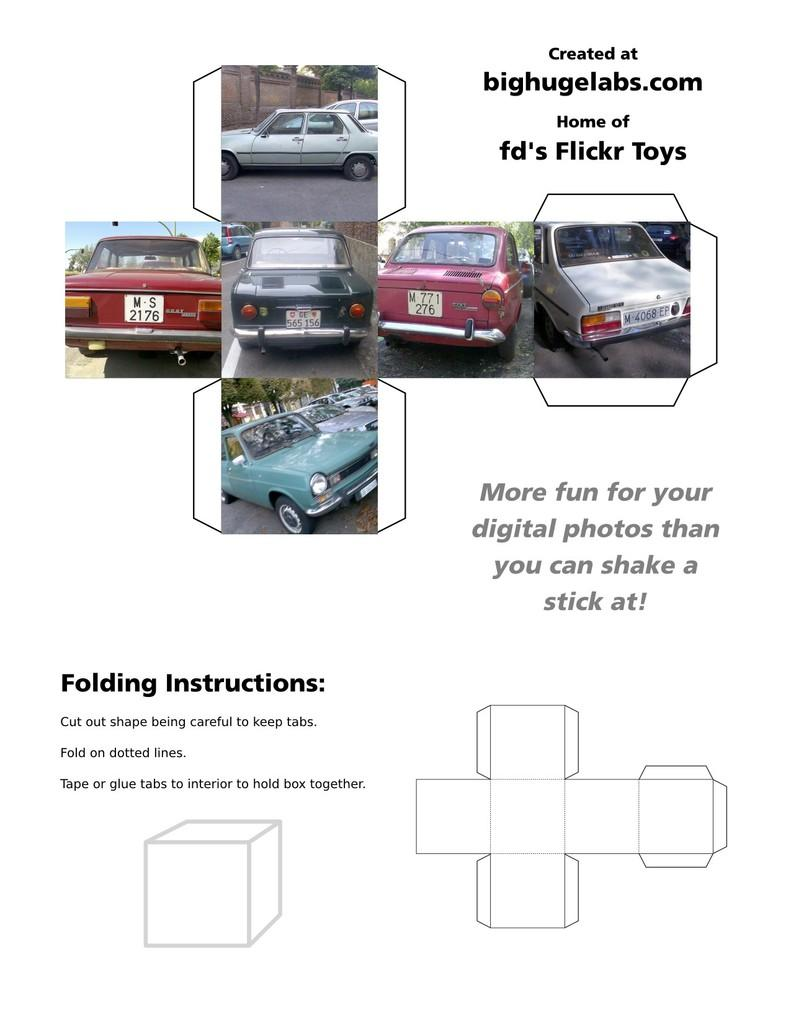What can be seen on the road in the image? There are vehicles on the road in the image. What else is present in the image besides the vehicles? There is text written in the image. How many bikes are present in the image? There is no mention of bikes in the provided facts, so we cannot determine the number of bikes in the image. What type of knowledge is being conveyed through the text in the image? The provided facts do not give any information about the content of the text, so we cannot determine the type of knowledge being conveyed. 